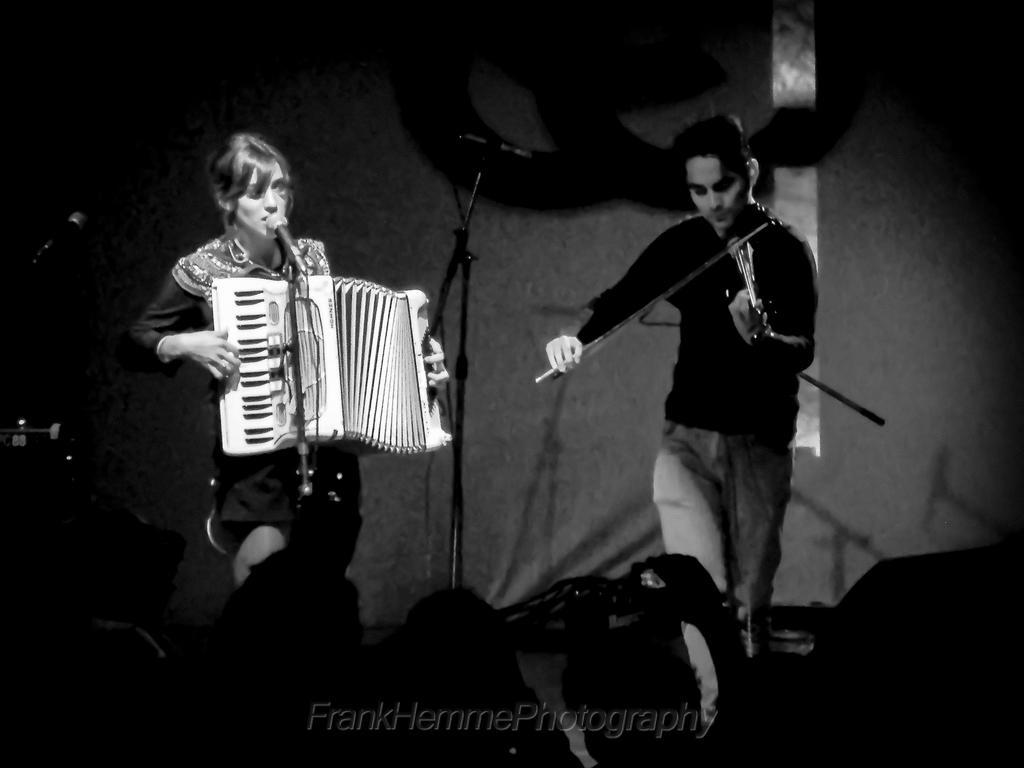How would you summarize this image in a sentence or two? There is a woman playing piano and singing in front of a mic and there is another person beside her playing violin and there are few audience in front of them. 